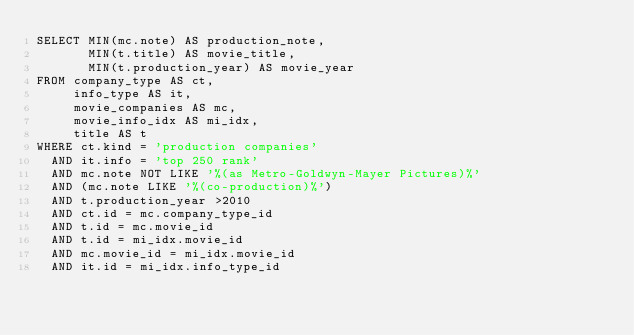Convert code to text. <code><loc_0><loc_0><loc_500><loc_500><_SQL_>SELECT MIN(mc.note) AS production_note,
       MIN(t.title) AS movie_title,
       MIN(t.production_year) AS movie_year
FROM company_type AS ct,
     info_type AS it,
     movie_companies AS mc,
     movie_info_idx AS mi_idx,
     title AS t
WHERE ct.kind = 'production companies'
  AND it.info = 'top 250 rank'
  AND mc.note NOT LIKE '%(as Metro-Goldwyn-Mayer Pictures)%'
  AND (mc.note LIKE '%(co-production)%')
  AND t.production_year >2010
  AND ct.id = mc.company_type_id
  AND t.id = mc.movie_id
  AND t.id = mi_idx.movie_id
  AND mc.movie_id = mi_idx.movie_id
  AND it.id = mi_idx.info_type_id
</code> 